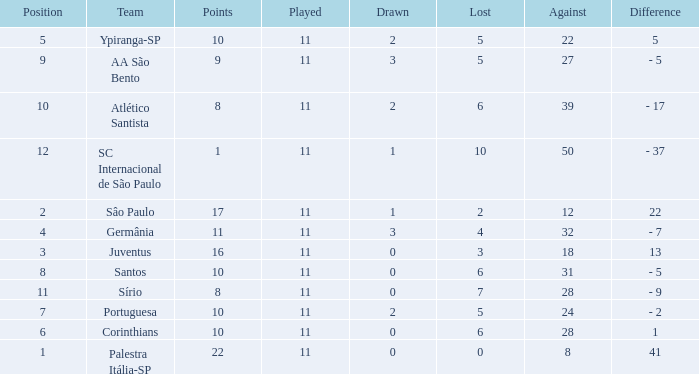Calculate the total points when the difference value is 13 and the lost value is greater than 3. None. 